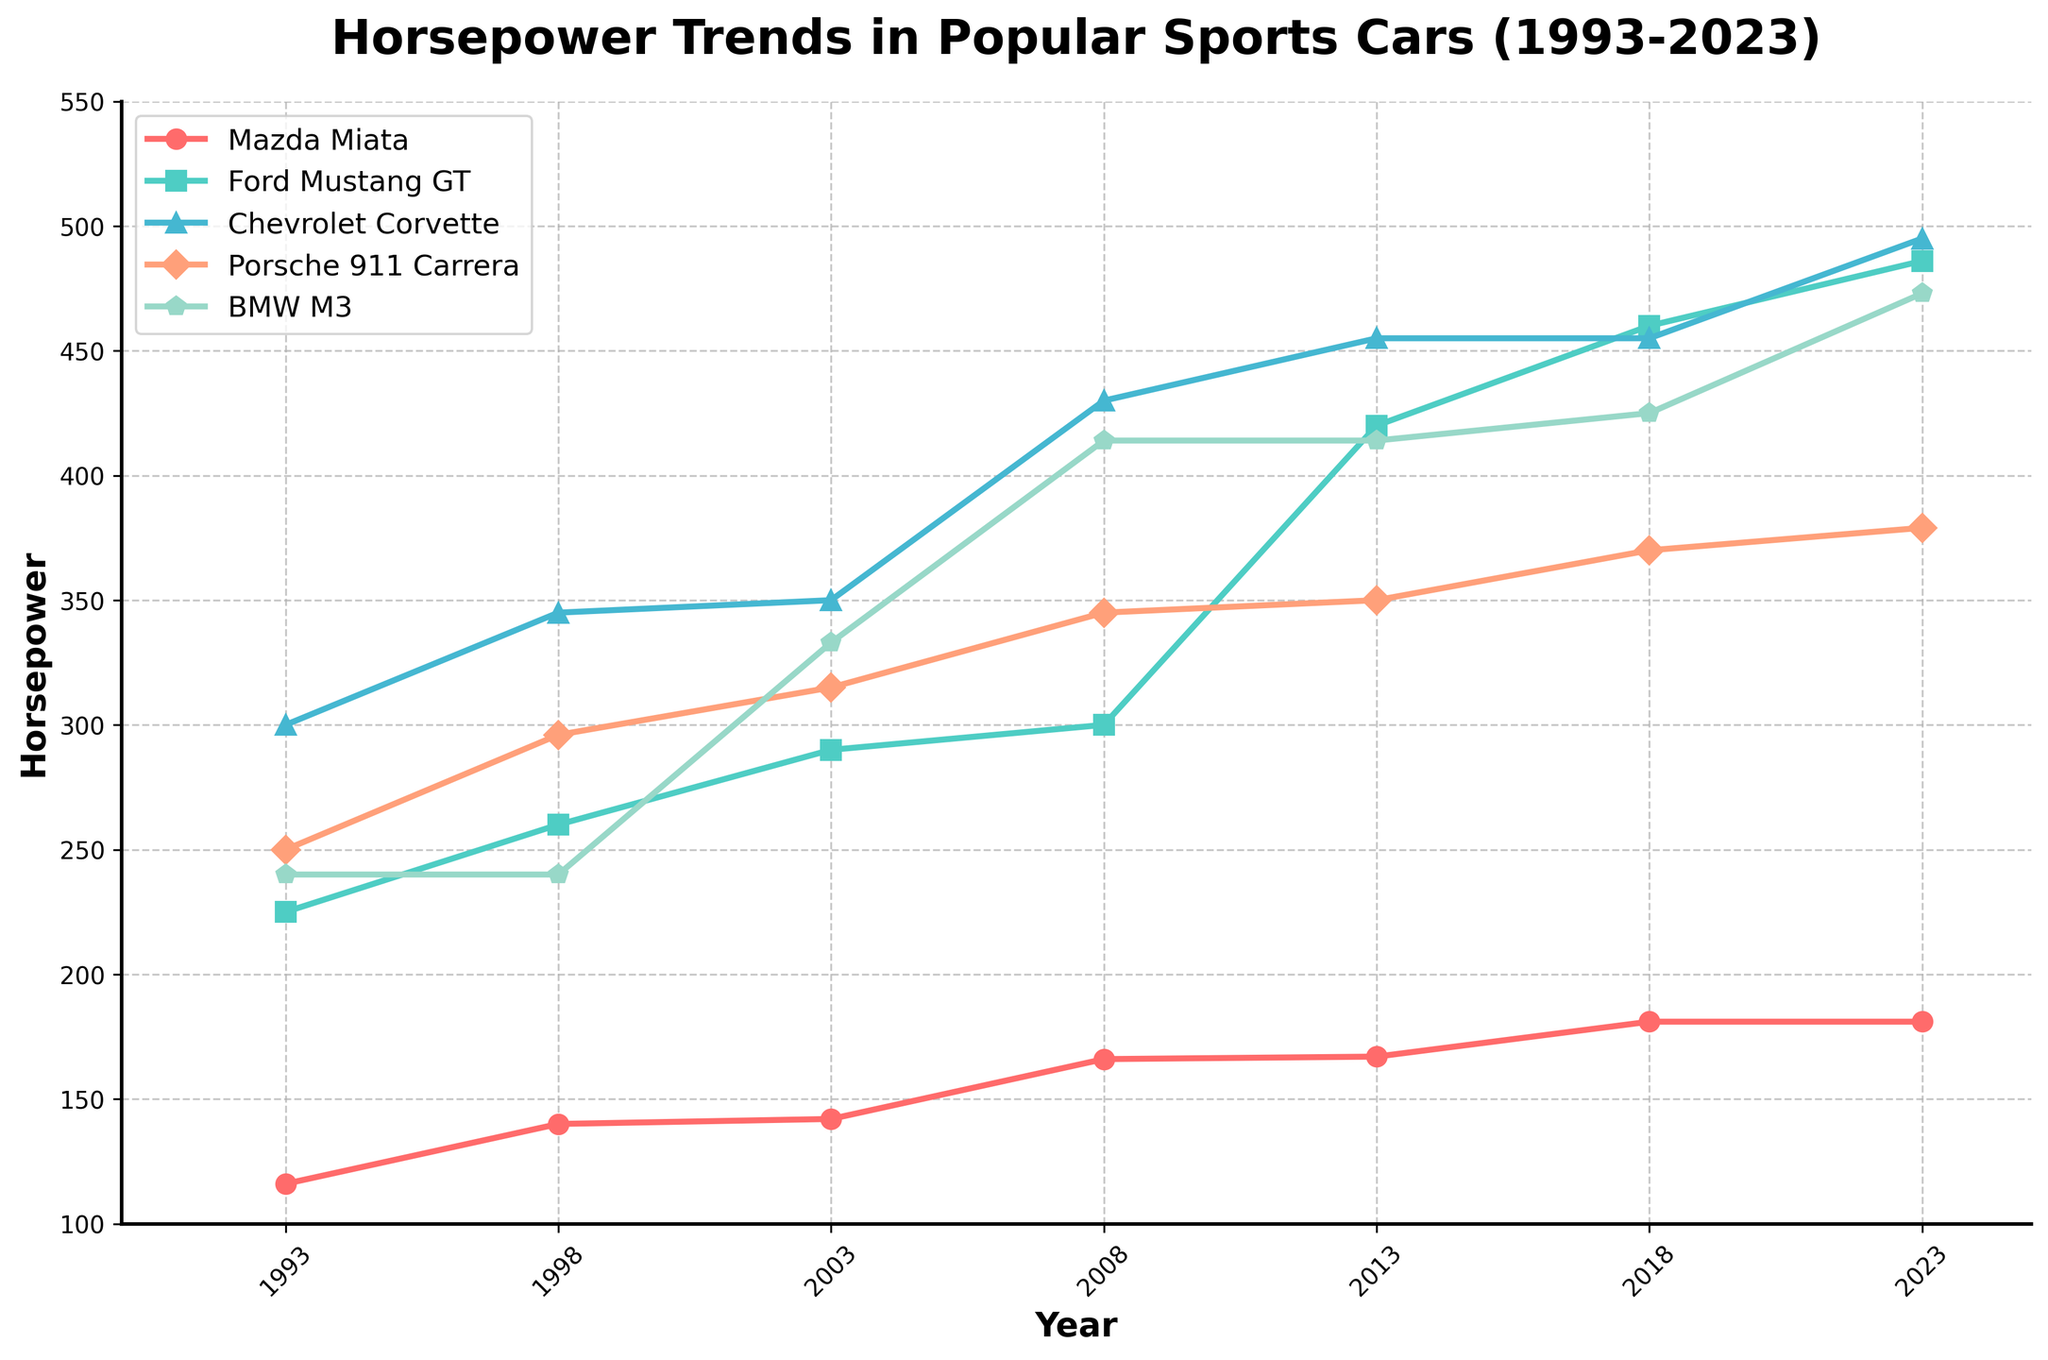Which car has the highest horsepower in 2023? In 2023, the horsepower values for each car model can be seen through their respective lines and markers. The Chevrolet Corvette reaches the highest point on the y-axis at 495 horsepower.
Answer: Chevrolet Corvette Which car shows the most consistent horsepower values over the years? The Mazda Miata has the least variation in horsepower, as its line appears to be the most horizontal and stable over the years, ranging from 116 to 181 horsepower.
Answer: Mazda Miata Between which consecutive years did the Ford Mustang GT experience the largest increase in horsepower? Examine the slope of the line for the Ford Mustang GT. The steepest increase occurs between 2008 and 2013, where it jumps from 300 to 420 horsepower.
Answer: 2008 to 2013 What is the difference in horsepower between the Porsche 911 Carrera and the BMW M3 in 2023? In 2023, the Porsche 911 Carrera has 379 horsepower, and the BMW M3 has 473 horsepower. The difference between them is calculated as 473 - 379.
Answer: 94 What is the average horsepower of the Chevrolet Corvette across all presented years? The horsepower of the Chevrolet Corvette in each year is 300, 345, 350, 430, 455, 455, and 495. Sum these values and divide by the number of years: (300 + 345 + 350 + 430 + 455 + 455 + 495) / 7.
Answer: 404.29 How does the horsepower trend of the BMW M3 compare to that of the Mazda Miata from 1993 to 2023? The BMW M3 shows a significant upward trend with horsepower increasing from 240 to 473. The Mazda Miata also shows an increase but much smaller, from 116 to 181. The BMW M3's line is steeper compared to the flatter line of the Miata.
Answer: BMW M3 shows a steeper increase Which car had the highest jump in horsepower between 1998 and 2003? Compare the differences in horsepower for each car between these years. The BMW M3 went from 240 to 333 horsepower, which is a 93 horsepower increase, the largest among the cars.
Answer: BMW M3 What is the visual difference between the Mazda Miata and the Porsche 911 Carrera in terms of their markers and colors? The Mazda Miata line uses circular markers and red color while the Porsche 911 Carrera line uses triangular markers and salmon color.
Answer: Circular markers and red vs. triangular markers and salmon In which year do all five cars have the maximum combined horsepower, and what is that value? Adding up the horsepower values for each year: 
1993 = 116 + 225 + 300 + 250 + 240 = 1131 
1998 = 140 + 260 + 345 + 296 + 240 = 1281 
2003 = 142 + 290 + 350 + 315 + 333 = 1430 
2008 = 166 + 300 + 430 + 345 + 414 = 1655 
2013 = 167 + 420 + 455 + 350 + 414 = 1806 
2018 = 181 + 460 + 455 + 370 + 425 = 1891 
2023 = 181 + 486 + 495 + 379 + 473 = 2014
2014 is the highest value, in 2023.
Answer: 2023, 2014 